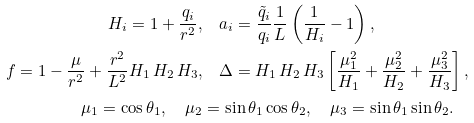Convert formula to latex. <formula><loc_0><loc_0><loc_500><loc_500>H _ { i } = 1 + \frac { q _ { i } } { r ^ { 2 } } , & \quad a _ { i } = \frac { { \tilde { q } } _ { i } } { q _ { i } } \frac { 1 } { L } \left ( \frac { 1 } { H _ { i } } - 1 \right ) , \\ f = 1 - \frac { \mu } { r ^ { 2 } } + \frac { r ^ { 2 } } { L ^ { 2 } } H _ { 1 } \, H _ { 2 } \, H _ { 3 } , & \quad \Delta = H _ { 1 } \, H _ { 2 } \, H _ { 3 } \left [ \frac { \mu _ { 1 } ^ { 2 } } { H _ { 1 } } + \frac { \mu _ { 2 } ^ { 2 } } { H _ { 2 } } + \frac { \mu _ { 3 } ^ { 2 } } { H _ { 3 } } \right ] , \\ \mu _ { 1 } = \cos \theta _ { 1 } , \quad \mu _ { 2 } & = \sin \theta _ { 1 } \cos \theta _ { 2 } , \quad \mu _ { 3 } = \sin \theta _ { 1 } \sin \theta _ { 2 } .</formula> 